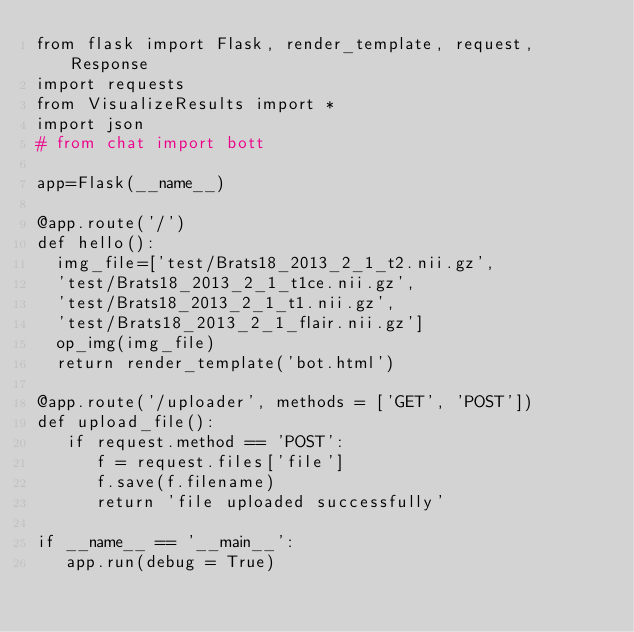Convert code to text. <code><loc_0><loc_0><loc_500><loc_500><_Python_>from flask import Flask, render_template, request, Response
import requests
from VisualizeResults import *
import json
# from chat import bott

app=Flask(__name__)

@app.route('/')
def hello():
  img_file=['test/Brats18_2013_2_1_t2.nii.gz',
  'test/Brats18_2013_2_1_t1ce.nii.gz',
  'test/Brats18_2013_2_1_t1.nii.gz',
  'test/Brats18_2013_2_1_flair.nii.gz']
  op_img(img_file)
  return render_template('bot.html')

@app.route('/uploader', methods = ['GET', 'POST'])
def upload_file():
   if request.method == 'POST':
      f = request.files['file']
      f.save(f.filename)
      return 'file uploaded successfully'

if __name__ == '__main__':
   app.run(debug = True)
</code> 